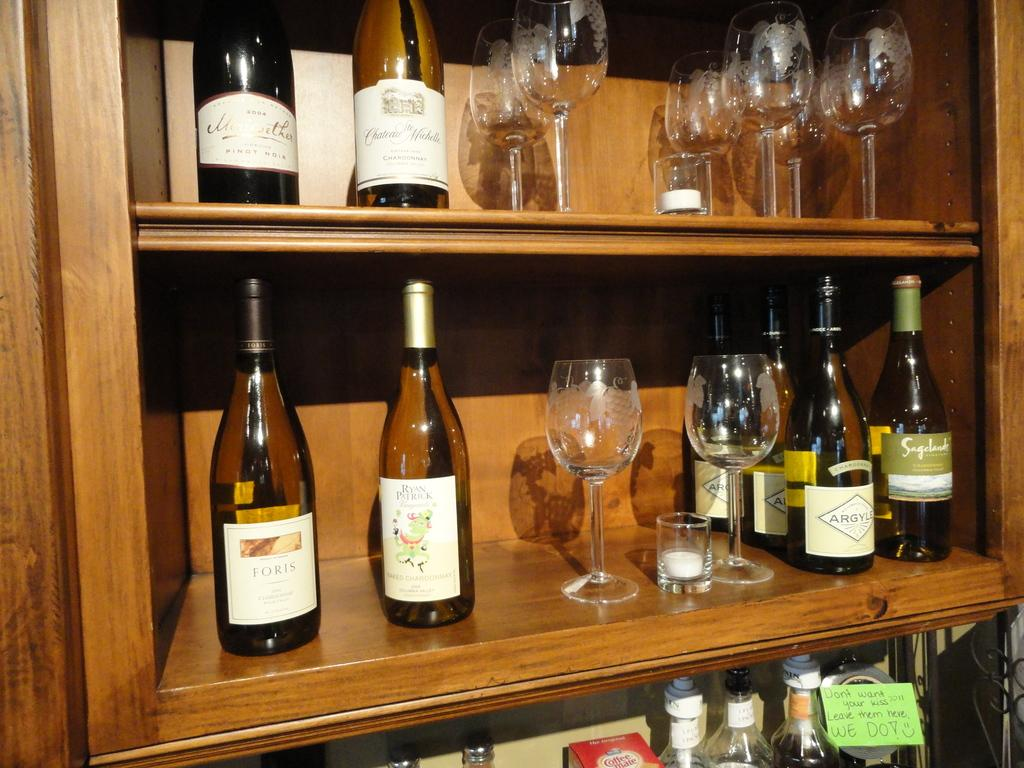<image>
Relay a brief, clear account of the picture shown. a Foris wine bottle that is on a shelf 